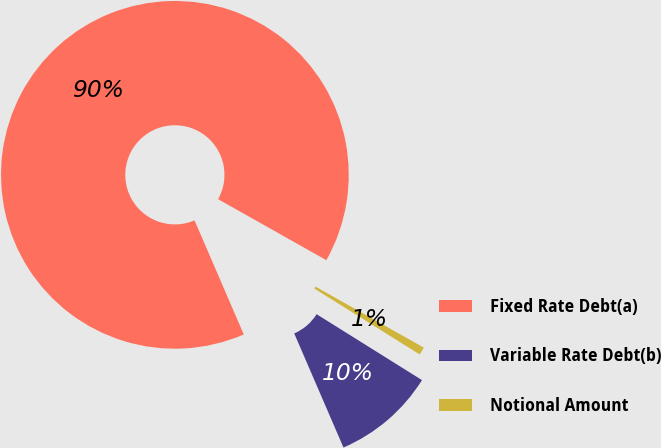Convert chart to OTSL. <chart><loc_0><loc_0><loc_500><loc_500><pie_chart><fcel>Fixed Rate Debt(a)<fcel>Variable Rate Debt(b)<fcel>Notional Amount<nl><fcel>89.66%<fcel>9.62%<fcel>0.73%<nl></chart> 